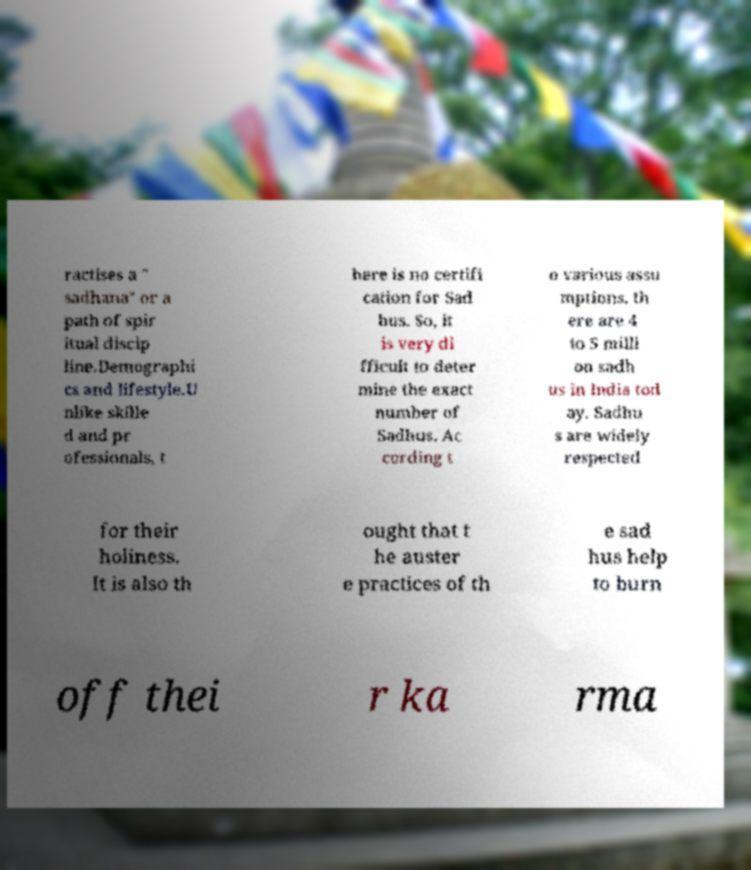Can you accurately transcribe the text from the provided image for me? ractises a ″ sadhana″ or a path of spir itual discip line.Demographi cs and lifestyle.U nlike skille d and pr ofessionals, t here is no certifi cation for Sad hus. So, it is very di fficult to deter mine the exact number of Sadhus. Ac cording t o various assu mptions, th ere are 4 to 5 milli on sadh us in India tod ay. Sadhu s are widely respected for their holiness. It is also th ought that t he auster e practices of th e sad hus help to burn off thei r ka rma 